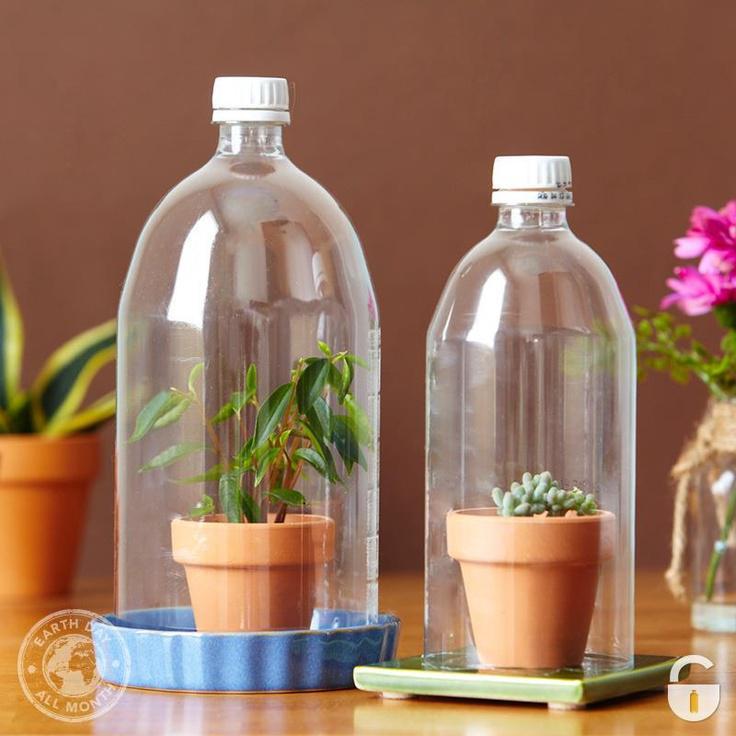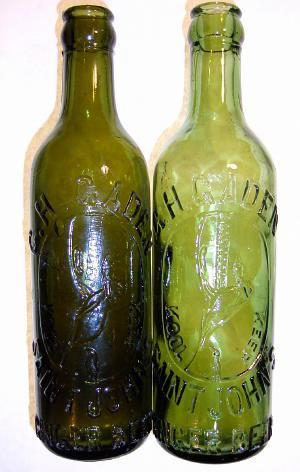The first image is the image on the left, the second image is the image on the right. Analyze the images presented: Is the assertion "One image shows a group of overlapping old-fashioned glass soda bottles with a variety of labels, shapes and sizes." valid? Answer yes or no. No. The first image is the image on the left, the second image is the image on the right. Evaluate the accuracy of this statement regarding the images: "The bottles in one of the images have been painted.". Is it true? Answer yes or no. No. 